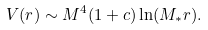Convert formula to latex. <formula><loc_0><loc_0><loc_500><loc_500>V ( r ) \sim M ^ { 4 } ( 1 + c ) \ln ( M _ { * } r ) .</formula> 